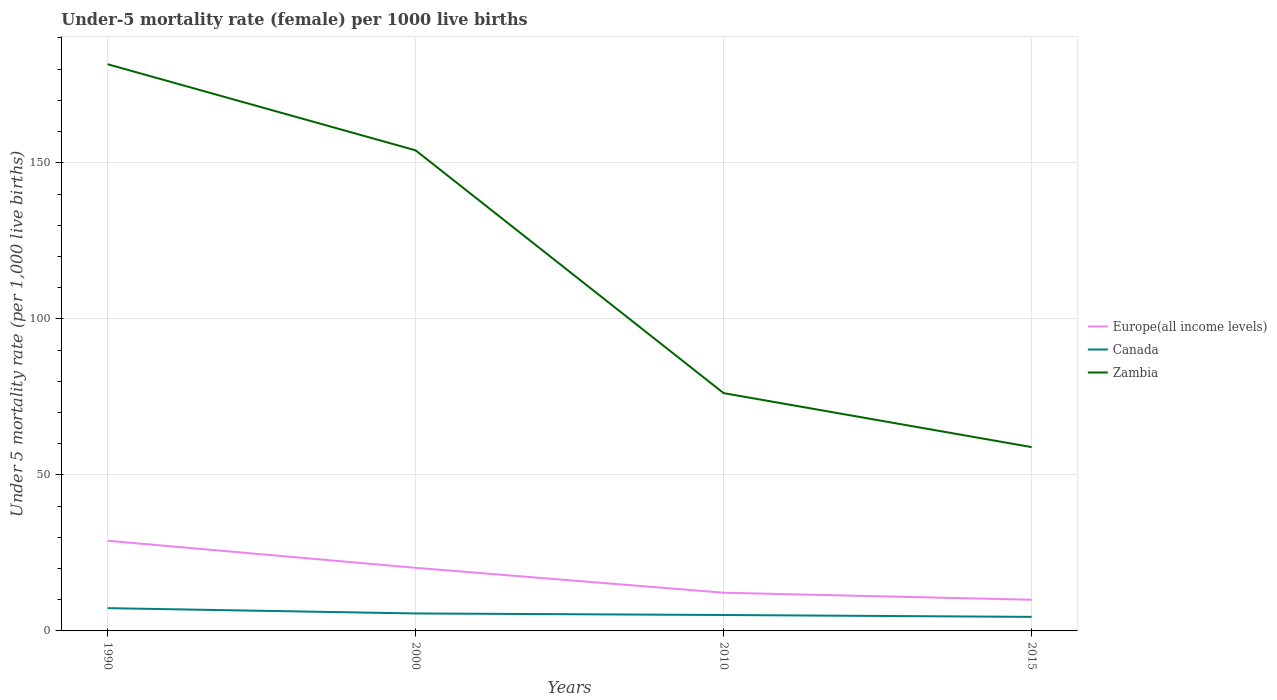How many different coloured lines are there?
Offer a terse response. 3. Is the number of lines equal to the number of legend labels?
Provide a short and direct response. Yes. Across all years, what is the maximum under-five mortality rate in Canada?
Give a very brief answer. 4.5. In which year was the under-five mortality rate in Canada maximum?
Make the answer very short. 2015. What is the total under-five mortality rate in Canada in the graph?
Your response must be concise. 1.7. How many lines are there?
Offer a terse response. 3. What is the difference between two consecutive major ticks on the Y-axis?
Your answer should be very brief. 50. Are the values on the major ticks of Y-axis written in scientific E-notation?
Keep it short and to the point. No. Does the graph contain any zero values?
Provide a short and direct response. No. What is the title of the graph?
Your answer should be very brief. Under-5 mortality rate (female) per 1000 live births. What is the label or title of the Y-axis?
Give a very brief answer. Under 5 mortality rate (per 1,0 live births). What is the Under 5 mortality rate (per 1,000 live births) of Europe(all income levels) in 1990?
Your response must be concise. 28.9. What is the Under 5 mortality rate (per 1,000 live births) of Canada in 1990?
Provide a short and direct response. 7.3. What is the Under 5 mortality rate (per 1,000 live births) in Zambia in 1990?
Give a very brief answer. 181.6. What is the Under 5 mortality rate (per 1,000 live births) in Europe(all income levels) in 2000?
Offer a terse response. 20.22. What is the Under 5 mortality rate (per 1,000 live births) in Canada in 2000?
Keep it short and to the point. 5.6. What is the Under 5 mortality rate (per 1,000 live births) in Zambia in 2000?
Give a very brief answer. 154. What is the Under 5 mortality rate (per 1,000 live births) in Europe(all income levels) in 2010?
Give a very brief answer. 12.24. What is the Under 5 mortality rate (per 1,000 live births) in Zambia in 2010?
Give a very brief answer. 76.2. What is the Under 5 mortality rate (per 1,000 live births) of Europe(all income levels) in 2015?
Your response must be concise. 9.99. What is the Under 5 mortality rate (per 1,000 live births) of Canada in 2015?
Your answer should be compact. 4.5. What is the Under 5 mortality rate (per 1,000 live births) in Zambia in 2015?
Give a very brief answer. 58.9. Across all years, what is the maximum Under 5 mortality rate (per 1,000 live births) of Europe(all income levels)?
Provide a succinct answer. 28.9. Across all years, what is the maximum Under 5 mortality rate (per 1,000 live births) of Zambia?
Your response must be concise. 181.6. Across all years, what is the minimum Under 5 mortality rate (per 1,000 live births) in Europe(all income levels)?
Offer a very short reply. 9.99. Across all years, what is the minimum Under 5 mortality rate (per 1,000 live births) of Zambia?
Your answer should be compact. 58.9. What is the total Under 5 mortality rate (per 1,000 live births) of Europe(all income levels) in the graph?
Your answer should be compact. 71.34. What is the total Under 5 mortality rate (per 1,000 live births) in Canada in the graph?
Your answer should be very brief. 22.5. What is the total Under 5 mortality rate (per 1,000 live births) of Zambia in the graph?
Your answer should be very brief. 470.7. What is the difference between the Under 5 mortality rate (per 1,000 live births) of Europe(all income levels) in 1990 and that in 2000?
Provide a short and direct response. 8.68. What is the difference between the Under 5 mortality rate (per 1,000 live births) of Canada in 1990 and that in 2000?
Your answer should be very brief. 1.7. What is the difference between the Under 5 mortality rate (per 1,000 live births) in Zambia in 1990 and that in 2000?
Give a very brief answer. 27.6. What is the difference between the Under 5 mortality rate (per 1,000 live births) of Europe(all income levels) in 1990 and that in 2010?
Offer a very short reply. 16.66. What is the difference between the Under 5 mortality rate (per 1,000 live births) of Zambia in 1990 and that in 2010?
Ensure brevity in your answer.  105.4. What is the difference between the Under 5 mortality rate (per 1,000 live births) in Europe(all income levels) in 1990 and that in 2015?
Ensure brevity in your answer.  18.9. What is the difference between the Under 5 mortality rate (per 1,000 live births) of Zambia in 1990 and that in 2015?
Provide a short and direct response. 122.7. What is the difference between the Under 5 mortality rate (per 1,000 live births) of Europe(all income levels) in 2000 and that in 2010?
Give a very brief answer. 7.98. What is the difference between the Under 5 mortality rate (per 1,000 live births) of Zambia in 2000 and that in 2010?
Keep it short and to the point. 77.8. What is the difference between the Under 5 mortality rate (per 1,000 live births) of Europe(all income levels) in 2000 and that in 2015?
Offer a terse response. 10.23. What is the difference between the Under 5 mortality rate (per 1,000 live births) of Zambia in 2000 and that in 2015?
Keep it short and to the point. 95.1. What is the difference between the Under 5 mortality rate (per 1,000 live births) in Europe(all income levels) in 2010 and that in 2015?
Your response must be concise. 2.25. What is the difference between the Under 5 mortality rate (per 1,000 live births) of Canada in 2010 and that in 2015?
Give a very brief answer. 0.6. What is the difference between the Under 5 mortality rate (per 1,000 live births) in Europe(all income levels) in 1990 and the Under 5 mortality rate (per 1,000 live births) in Canada in 2000?
Offer a terse response. 23.3. What is the difference between the Under 5 mortality rate (per 1,000 live births) of Europe(all income levels) in 1990 and the Under 5 mortality rate (per 1,000 live births) of Zambia in 2000?
Provide a succinct answer. -125.1. What is the difference between the Under 5 mortality rate (per 1,000 live births) in Canada in 1990 and the Under 5 mortality rate (per 1,000 live births) in Zambia in 2000?
Your response must be concise. -146.7. What is the difference between the Under 5 mortality rate (per 1,000 live births) of Europe(all income levels) in 1990 and the Under 5 mortality rate (per 1,000 live births) of Canada in 2010?
Keep it short and to the point. 23.8. What is the difference between the Under 5 mortality rate (per 1,000 live births) in Europe(all income levels) in 1990 and the Under 5 mortality rate (per 1,000 live births) in Zambia in 2010?
Ensure brevity in your answer.  -47.3. What is the difference between the Under 5 mortality rate (per 1,000 live births) in Canada in 1990 and the Under 5 mortality rate (per 1,000 live births) in Zambia in 2010?
Ensure brevity in your answer.  -68.9. What is the difference between the Under 5 mortality rate (per 1,000 live births) in Europe(all income levels) in 1990 and the Under 5 mortality rate (per 1,000 live births) in Canada in 2015?
Make the answer very short. 24.4. What is the difference between the Under 5 mortality rate (per 1,000 live births) in Europe(all income levels) in 1990 and the Under 5 mortality rate (per 1,000 live births) in Zambia in 2015?
Provide a succinct answer. -30. What is the difference between the Under 5 mortality rate (per 1,000 live births) in Canada in 1990 and the Under 5 mortality rate (per 1,000 live births) in Zambia in 2015?
Make the answer very short. -51.6. What is the difference between the Under 5 mortality rate (per 1,000 live births) of Europe(all income levels) in 2000 and the Under 5 mortality rate (per 1,000 live births) of Canada in 2010?
Give a very brief answer. 15.12. What is the difference between the Under 5 mortality rate (per 1,000 live births) in Europe(all income levels) in 2000 and the Under 5 mortality rate (per 1,000 live births) in Zambia in 2010?
Offer a terse response. -55.98. What is the difference between the Under 5 mortality rate (per 1,000 live births) of Canada in 2000 and the Under 5 mortality rate (per 1,000 live births) of Zambia in 2010?
Your answer should be compact. -70.6. What is the difference between the Under 5 mortality rate (per 1,000 live births) of Europe(all income levels) in 2000 and the Under 5 mortality rate (per 1,000 live births) of Canada in 2015?
Ensure brevity in your answer.  15.72. What is the difference between the Under 5 mortality rate (per 1,000 live births) of Europe(all income levels) in 2000 and the Under 5 mortality rate (per 1,000 live births) of Zambia in 2015?
Make the answer very short. -38.68. What is the difference between the Under 5 mortality rate (per 1,000 live births) in Canada in 2000 and the Under 5 mortality rate (per 1,000 live births) in Zambia in 2015?
Offer a very short reply. -53.3. What is the difference between the Under 5 mortality rate (per 1,000 live births) in Europe(all income levels) in 2010 and the Under 5 mortality rate (per 1,000 live births) in Canada in 2015?
Your answer should be very brief. 7.74. What is the difference between the Under 5 mortality rate (per 1,000 live births) in Europe(all income levels) in 2010 and the Under 5 mortality rate (per 1,000 live births) in Zambia in 2015?
Provide a short and direct response. -46.66. What is the difference between the Under 5 mortality rate (per 1,000 live births) in Canada in 2010 and the Under 5 mortality rate (per 1,000 live births) in Zambia in 2015?
Offer a terse response. -53.8. What is the average Under 5 mortality rate (per 1,000 live births) of Europe(all income levels) per year?
Offer a terse response. 17.84. What is the average Under 5 mortality rate (per 1,000 live births) of Canada per year?
Ensure brevity in your answer.  5.62. What is the average Under 5 mortality rate (per 1,000 live births) of Zambia per year?
Keep it short and to the point. 117.67. In the year 1990, what is the difference between the Under 5 mortality rate (per 1,000 live births) of Europe(all income levels) and Under 5 mortality rate (per 1,000 live births) of Canada?
Your answer should be compact. 21.6. In the year 1990, what is the difference between the Under 5 mortality rate (per 1,000 live births) of Europe(all income levels) and Under 5 mortality rate (per 1,000 live births) of Zambia?
Make the answer very short. -152.7. In the year 1990, what is the difference between the Under 5 mortality rate (per 1,000 live births) of Canada and Under 5 mortality rate (per 1,000 live births) of Zambia?
Your response must be concise. -174.3. In the year 2000, what is the difference between the Under 5 mortality rate (per 1,000 live births) in Europe(all income levels) and Under 5 mortality rate (per 1,000 live births) in Canada?
Make the answer very short. 14.62. In the year 2000, what is the difference between the Under 5 mortality rate (per 1,000 live births) in Europe(all income levels) and Under 5 mortality rate (per 1,000 live births) in Zambia?
Keep it short and to the point. -133.78. In the year 2000, what is the difference between the Under 5 mortality rate (per 1,000 live births) of Canada and Under 5 mortality rate (per 1,000 live births) of Zambia?
Provide a succinct answer. -148.4. In the year 2010, what is the difference between the Under 5 mortality rate (per 1,000 live births) in Europe(all income levels) and Under 5 mortality rate (per 1,000 live births) in Canada?
Provide a succinct answer. 7.14. In the year 2010, what is the difference between the Under 5 mortality rate (per 1,000 live births) in Europe(all income levels) and Under 5 mortality rate (per 1,000 live births) in Zambia?
Offer a very short reply. -63.96. In the year 2010, what is the difference between the Under 5 mortality rate (per 1,000 live births) of Canada and Under 5 mortality rate (per 1,000 live births) of Zambia?
Your answer should be very brief. -71.1. In the year 2015, what is the difference between the Under 5 mortality rate (per 1,000 live births) in Europe(all income levels) and Under 5 mortality rate (per 1,000 live births) in Canada?
Give a very brief answer. 5.49. In the year 2015, what is the difference between the Under 5 mortality rate (per 1,000 live births) of Europe(all income levels) and Under 5 mortality rate (per 1,000 live births) of Zambia?
Offer a very short reply. -48.91. In the year 2015, what is the difference between the Under 5 mortality rate (per 1,000 live births) of Canada and Under 5 mortality rate (per 1,000 live births) of Zambia?
Offer a terse response. -54.4. What is the ratio of the Under 5 mortality rate (per 1,000 live births) in Europe(all income levels) in 1990 to that in 2000?
Provide a succinct answer. 1.43. What is the ratio of the Under 5 mortality rate (per 1,000 live births) in Canada in 1990 to that in 2000?
Provide a short and direct response. 1.3. What is the ratio of the Under 5 mortality rate (per 1,000 live births) of Zambia in 1990 to that in 2000?
Give a very brief answer. 1.18. What is the ratio of the Under 5 mortality rate (per 1,000 live births) in Europe(all income levels) in 1990 to that in 2010?
Provide a succinct answer. 2.36. What is the ratio of the Under 5 mortality rate (per 1,000 live births) of Canada in 1990 to that in 2010?
Your response must be concise. 1.43. What is the ratio of the Under 5 mortality rate (per 1,000 live births) in Zambia in 1990 to that in 2010?
Provide a succinct answer. 2.38. What is the ratio of the Under 5 mortality rate (per 1,000 live births) in Europe(all income levels) in 1990 to that in 2015?
Your answer should be very brief. 2.89. What is the ratio of the Under 5 mortality rate (per 1,000 live births) in Canada in 1990 to that in 2015?
Ensure brevity in your answer.  1.62. What is the ratio of the Under 5 mortality rate (per 1,000 live births) of Zambia in 1990 to that in 2015?
Your answer should be very brief. 3.08. What is the ratio of the Under 5 mortality rate (per 1,000 live births) of Europe(all income levels) in 2000 to that in 2010?
Your answer should be compact. 1.65. What is the ratio of the Under 5 mortality rate (per 1,000 live births) in Canada in 2000 to that in 2010?
Make the answer very short. 1.1. What is the ratio of the Under 5 mortality rate (per 1,000 live births) of Zambia in 2000 to that in 2010?
Offer a very short reply. 2.02. What is the ratio of the Under 5 mortality rate (per 1,000 live births) in Europe(all income levels) in 2000 to that in 2015?
Offer a very short reply. 2.02. What is the ratio of the Under 5 mortality rate (per 1,000 live births) of Canada in 2000 to that in 2015?
Make the answer very short. 1.24. What is the ratio of the Under 5 mortality rate (per 1,000 live births) of Zambia in 2000 to that in 2015?
Make the answer very short. 2.61. What is the ratio of the Under 5 mortality rate (per 1,000 live births) of Europe(all income levels) in 2010 to that in 2015?
Your response must be concise. 1.22. What is the ratio of the Under 5 mortality rate (per 1,000 live births) of Canada in 2010 to that in 2015?
Your response must be concise. 1.13. What is the ratio of the Under 5 mortality rate (per 1,000 live births) of Zambia in 2010 to that in 2015?
Your answer should be very brief. 1.29. What is the difference between the highest and the second highest Under 5 mortality rate (per 1,000 live births) of Europe(all income levels)?
Your answer should be compact. 8.68. What is the difference between the highest and the second highest Under 5 mortality rate (per 1,000 live births) of Canada?
Your answer should be compact. 1.7. What is the difference between the highest and the second highest Under 5 mortality rate (per 1,000 live births) of Zambia?
Ensure brevity in your answer.  27.6. What is the difference between the highest and the lowest Under 5 mortality rate (per 1,000 live births) in Europe(all income levels)?
Keep it short and to the point. 18.9. What is the difference between the highest and the lowest Under 5 mortality rate (per 1,000 live births) in Zambia?
Your answer should be very brief. 122.7. 